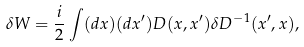<formula> <loc_0><loc_0><loc_500><loc_500>\delta W = { \frac { i } { 2 } } \int ( d x ) ( d x ^ { \prime } ) D ( x , x ^ { \prime } ) \delta D ^ { - 1 } ( x ^ { \prime } , x ) ,</formula> 